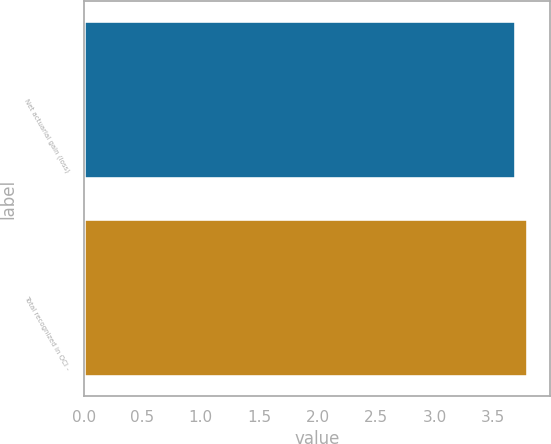<chart> <loc_0><loc_0><loc_500><loc_500><bar_chart><fcel>Net actuarial gain (loss)<fcel>Total recognized in OCI -<nl><fcel>3.7<fcel>3.8<nl></chart> 